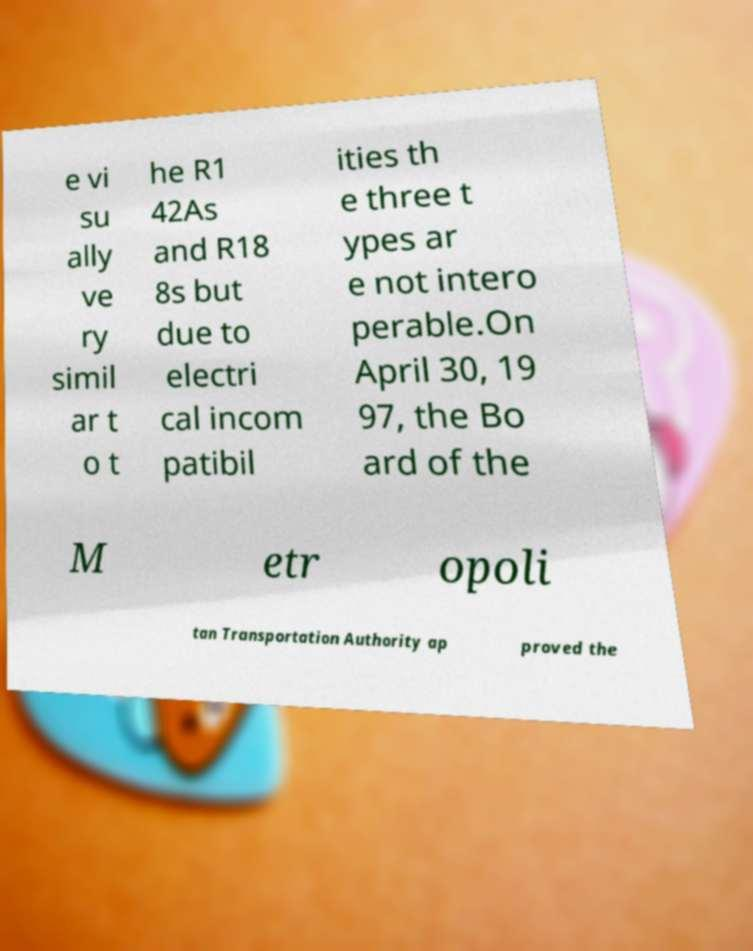Please read and relay the text visible in this image. What does it say? e vi su ally ve ry simil ar t o t he R1 42As and R18 8s but due to electri cal incom patibil ities th e three t ypes ar e not intero perable.On April 30, 19 97, the Bo ard of the M etr opoli tan Transportation Authority ap proved the 